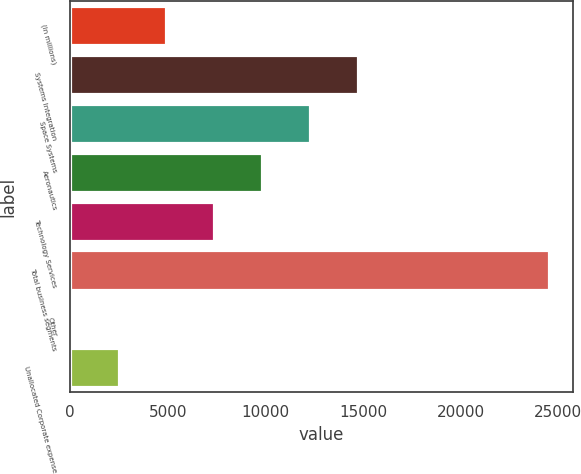<chart> <loc_0><loc_0><loc_500><loc_500><bar_chart><fcel>(In millions)<fcel>Systems Integration<fcel>Space Systems<fcel>Aeronautics<fcel>Technology Services<fcel>Total business segments<fcel>Other<fcel>Unallocated Corporate expense<nl><fcel>4920.8<fcel>14720.4<fcel>12270.5<fcel>9820.6<fcel>7370.7<fcel>24520<fcel>21<fcel>2470.9<nl></chart> 